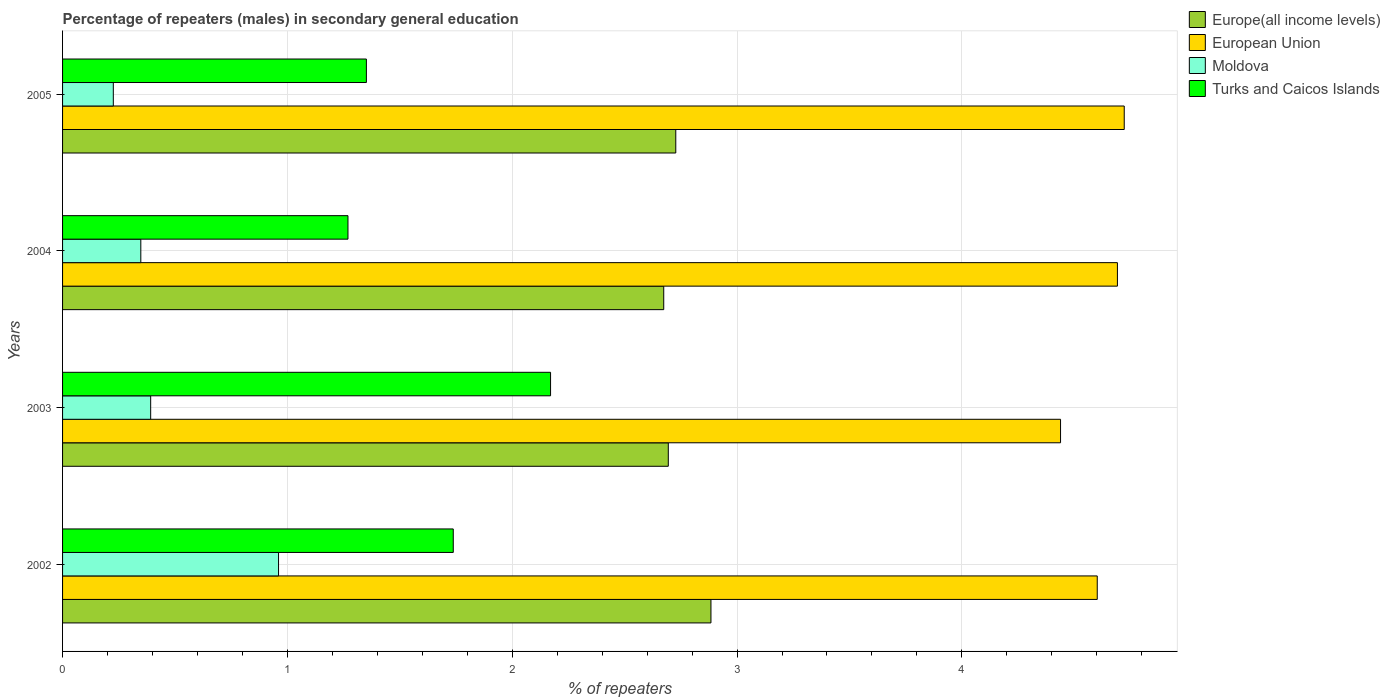Are the number of bars per tick equal to the number of legend labels?
Provide a short and direct response. Yes. Are the number of bars on each tick of the Y-axis equal?
Your answer should be very brief. Yes. How many bars are there on the 4th tick from the bottom?
Provide a succinct answer. 4. In how many cases, is the number of bars for a given year not equal to the number of legend labels?
Offer a very short reply. 0. What is the percentage of male repeaters in Moldova in 2005?
Offer a terse response. 0.23. Across all years, what is the maximum percentage of male repeaters in European Union?
Keep it short and to the point. 4.72. Across all years, what is the minimum percentage of male repeaters in European Union?
Give a very brief answer. 4.44. In which year was the percentage of male repeaters in Turks and Caicos Islands minimum?
Keep it short and to the point. 2004. What is the total percentage of male repeaters in Europe(all income levels) in the graph?
Make the answer very short. 10.98. What is the difference between the percentage of male repeaters in Moldova in 2003 and that in 2005?
Your response must be concise. 0.17. What is the difference between the percentage of male repeaters in Turks and Caicos Islands in 2005 and the percentage of male repeaters in Moldova in 2002?
Ensure brevity in your answer.  0.39. What is the average percentage of male repeaters in Turks and Caicos Islands per year?
Your answer should be very brief. 1.63. In the year 2003, what is the difference between the percentage of male repeaters in Moldova and percentage of male repeaters in European Union?
Provide a short and direct response. -4.05. What is the ratio of the percentage of male repeaters in Moldova in 2004 to that in 2005?
Give a very brief answer. 1.54. What is the difference between the highest and the second highest percentage of male repeaters in Moldova?
Provide a short and direct response. 0.57. What is the difference between the highest and the lowest percentage of male repeaters in Turks and Caicos Islands?
Keep it short and to the point. 0.9. Is the sum of the percentage of male repeaters in Moldova in 2002 and 2004 greater than the maximum percentage of male repeaters in European Union across all years?
Make the answer very short. No. What does the 2nd bar from the top in 2003 represents?
Your answer should be very brief. Moldova. Is it the case that in every year, the sum of the percentage of male repeaters in Turks and Caicos Islands and percentage of male repeaters in Moldova is greater than the percentage of male repeaters in Europe(all income levels)?
Your answer should be compact. No. How many bars are there?
Provide a short and direct response. 16. What is the difference between two consecutive major ticks on the X-axis?
Make the answer very short. 1. Are the values on the major ticks of X-axis written in scientific E-notation?
Your answer should be compact. No. Does the graph contain any zero values?
Keep it short and to the point. No. Does the graph contain grids?
Provide a succinct answer. Yes. Where does the legend appear in the graph?
Keep it short and to the point. Top right. How many legend labels are there?
Your response must be concise. 4. How are the legend labels stacked?
Make the answer very short. Vertical. What is the title of the graph?
Keep it short and to the point. Percentage of repeaters (males) in secondary general education. What is the label or title of the X-axis?
Provide a succinct answer. % of repeaters. What is the label or title of the Y-axis?
Your answer should be compact. Years. What is the % of repeaters in Europe(all income levels) in 2002?
Make the answer very short. 2.88. What is the % of repeaters of European Union in 2002?
Ensure brevity in your answer.  4.6. What is the % of repeaters of Moldova in 2002?
Provide a succinct answer. 0.96. What is the % of repeaters in Turks and Caicos Islands in 2002?
Offer a terse response. 1.74. What is the % of repeaters of Europe(all income levels) in 2003?
Your answer should be very brief. 2.69. What is the % of repeaters of European Union in 2003?
Ensure brevity in your answer.  4.44. What is the % of repeaters of Moldova in 2003?
Keep it short and to the point. 0.39. What is the % of repeaters of Turks and Caicos Islands in 2003?
Keep it short and to the point. 2.17. What is the % of repeaters in Europe(all income levels) in 2004?
Your answer should be compact. 2.67. What is the % of repeaters of European Union in 2004?
Make the answer very short. 4.69. What is the % of repeaters of Moldova in 2004?
Provide a succinct answer. 0.35. What is the % of repeaters in Turks and Caicos Islands in 2004?
Provide a short and direct response. 1.27. What is the % of repeaters of Europe(all income levels) in 2005?
Your answer should be very brief. 2.73. What is the % of repeaters in European Union in 2005?
Provide a short and direct response. 4.72. What is the % of repeaters of Moldova in 2005?
Provide a succinct answer. 0.23. What is the % of repeaters in Turks and Caicos Islands in 2005?
Make the answer very short. 1.35. Across all years, what is the maximum % of repeaters in Europe(all income levels)?
Keep it short and to the point. 2.88. Across all years, what is the maximum % of repeaters in European Union?
Offer a terse response. 4.72. Across all years, what is the maximum % of repeaters of Moldova?
Offer a very short reply. 0.96. Across all years, what is the maximum % of repeaters in Turks and Caicos Islands?
Give a very brief answer. 2.17. Across all years, what is the minimum % of repeaters of Europe(all income levels)?
Your response must be concise. 2.67. Across all years, what is the minimum % of repeaters in European Union?
Your response must be concise. 4.44. Across all years, what is the minimum % of repeaters in Moldova?
Your answer should be compact. 0.23. Across all years, what is the minimum % of repeaters in Turks and Caicos Islands?
Give a very brief answer. 1.27. What is the total % of repeaters in Europe(all income levels) in the graph?
Your answer should be compact. 10.98. What is the total % of repeaters of European Union in the graph?
Give a very brief answer. 18.45. What is the total % of repeaters in Moldova in the graph?
Offer a terse response. 1.93. What is the total % of repeaters of Turks and Caicos Islands in the graph?
Offer a very short reply. 6.53. What is the difference between the % of repeaters of Europe(all income levels) in 2002 and that in 2003?
Provide a succinct answer. 0.19. What is the difference between the % of repeaters in European Union in 2002 and that in 2003?
Your answer should be very brief. 0.16. What is the difference between the % of repeaters of Moldova in 2002 and that in 2003?
Keep it short and to the point. 0.57. What is the difference between the % of repeaters in Turks and Caicos Islands in 2002 and that in 2003?
Ensure brevity in your answer.  -0.43. What is the difference between the % of repeaters of Europe(all income levels) in 2002 and that in 2004?
Your response must be concise. 0.21. What is the difference between the % of repeaters of European Union in 2002 and that in 2004?
Your answer should be compact. -0.09. What is the difference between the % of repeaters in Moldova in 2002 and that in 2004?
Give a very brief answer. 0.61. What is the difference between the % of repeaters in Turks and Caicos Islands in 2002 and that in 2004?
Ensure brevity in your answer.  0.47. What is the difference between the % of repeaters of Europe(all income levels) in 2002 and that in 2005?
Give a very brief answer. 0.16. What is the difference between the % of repeaters in European Union in 2002 and that in 2005?
Offer a very short reply. -0.12. What is the difference between the % of repeaters in Moldova in 2002 and that in 2005?
Your response must be concise. 0.73. What is the difference between the % of repeaters of Turks and Caicos Islands in 2002 and that in 2005?
Your response must be concise. 0.39. What is the difference between the % of repeaters in Europe(all income levels) in 2003 and that in 2004?
Provide a succinct answer. 0.02. What is the difference between the % of repeaters in European Union in 2003 and that in 2004?
Your answer should be very brief. -0.25. What is the difference between the % of repeaters of Moldova in 2003 and that in 2004?
Your answer should be very brief. 0.04. What is the difference between the % of repeaters in Turks and Caicos Islands in 2003 and that in 2004?
Your answer should be compact. 0.9. What is the difference between the % of repeaters in Europe(all income levels) in 2003 and that in 2005?
Your answer should be very brief. -0.03. What is the difference between the % of repeaters of European Union in 2003 and that in 2005?
Make the answer very short. -0.28. What is the difference between the % of repeaters in Moldova in 2003 and that in 2005?
Your response must be concise. 0.17. What is the difference between the % of repeaters of Turks and Caicos Islands in 2003 and that in 2005?
Offer a very short reply. 0.82. What is the difference between the % of repeaters of Europe(all income levels) in 2004 and that in 2005?
Provide a short and direct response. -0.05. What is the difference between the % of repeaters in European Union in 2004 and that in 2005?
Your response must be concise. -0.03. What is the difference between the % of repeaters of Moldova in 2004 and that in 2005?
Offer a terse response. 0.12. What is the difference between the % of repeaters of Turks and Caicos Islands in 2004 and that in 2005?
Your answer should be compact. -0.08. What is the difference between the % of repeaters of Europe(all income levels) in 2002 and the % of repeaters of European Union in 2003?
Your answer should be very brief. -1.55. What is the difference between the % of repeaters in Europe(all income levels) in 2002 and the % of repeaters in Moldova in 2003?
Keep it short and to the point. 2.49. What is the difference between the % of repeaters of Europe(all income levels) in 2002 and the % of repeaters of Turks and Caicos Islands in 2003?
Your response must be concise. 0.71. What is the difference between the % of repeaters of European Union in 2002 and the % of repeaters of Moldova in 2003?
Give a very brief answer. 4.21. What is the difference between the % of repeaters in European Union in 2002 and the % of repeaters in Turks and Caicos Islands in 2003?
Make the answer very short. 2.43. What is the difference between the % of repeaters in Moldova in 2002 and the % of repeaters in Turks and Caicos Islands in 2003?
Provide a succinct answer. -1.21. What is the difference between the % of repeaters of Europe(all income levels) in 2002 and the % of repeaters of European Union in 2004?
Provide a short and direct response. -1.81. What is the difference between the % of repeaters in Europe(all income levels) in 2002 and the % of repeaters in Moldova in 2004?
Provide a short and direct response. 2.54. What is the difference between the % of repeaters of Europe(all income levels) in 2002 and the % of repeaters of Turks and Caicos Islands in 2004?
Offer a terse response. 1.61. What is the difference between the % of repeaters of European Union in 2002 and the % of repeaters of Moldova in 2004?
Your answer should be compact. 4.25. What is the difference between the % of repeaters in European Union in 2002 and the % of repeaters in Turks and Caicos Islands in 2004?
Your answer should be very brief. 3.33. What is the difference between the % of repeaters in Moldova in 2002 and the % of repeaters in Turks and Caicos Islands in 2004?
Give a very brief answer. -0.31. What is the difference between the % of repeaters of Europe(all income levels) in 2002 and the % of repeaters of European Union in 2005?
Offer a very short reply. -1.84. What is the difference between the % of repeaters of Europe(all income levels) in 2002 and the % of repeaters of Moldova in 2005?
Provide a short and direct response. 2.66. What is the difference between the % of repeaters in Europe(all income levels) in 2002 and the % of repeaters in Turks and Caicos Islands in 2005?
Provide a succinct answer. 1.53. What is the difference between the % of repeaters of European Union in 2002 and the % of repeaters of Moldova in 2005?
Keep it short and to the point. 4.38. What is the difference between the % of repeaters in European Union in 2002 and the % of repeaters in Turks and Caicos Islands in 2005?
Provide a succinct answer. 3.25. What is the difference between the % of repeaters of Moldova in 2002 and the % of repeaters of Turks and Caicos Islands in 2005?
Give a very brief answer. -0.39. What is the difference between the % of repeaters of Europe(all income levels) in 2003 and the % of repeaters of European Union in 2004?
Your answer should be very brief. -2. What is the difference between the % of repeaters in Europe(all income levels) in 2003 and the % of repeaters in Moldova in 2004?
Provide a short and direct response. 2.35. What is the difference between the % of repeaters of Europe(all income levels) in 2003 and the % of repeaters of Turks and Caicos Islands in 2004?
Your answer should be compact. 1.42. What is the difference between the % of repeaters in European Union in 2003 and the % of repeaters in Moldova in 2004?
Make the answer very short. 4.09. What is the difference between the % of repeaters of European Union in 2003 and the % of repeaters of Turks and Caicos Islands in 2004?
Your answer should be compact. 3.17. What is the difference between the % of repeaters of Moldova in 2003 and the % of repeaters of Turks and Caicos Islands in 2004?
Your answer should be compact. -0.88. What is the difference between the % of repeaters of Europe(all income levels) in 2003 and the % of repeaters of European Union in 2005?
Give a very brief answer. -2.03. What is the difference between the % of repeaters in Europe(all income levels) in 2003 and the % of repeaters in Moldova in 2005?
Ensure brevity in your answer.  2.47. What is the difference between the % of repeaters in Europe(all income levels) in 2003 and the % of repeaters in Turks and Caicos Islands in 2005?
Your response must be concise. 1.34. What is the difference between the % of repeaters in European Union in 2003 and the % of repeaters in Moldova in 2005?
Provide a short and direct response. 4.21. What is the difference between the % of repeaters in European Union in 2003 and the % of repeaters in Turks and Caicos Islands in 2005?
Your answer should be very brief. 3.09. What is the difference between the % of repeaters of Moldova in 2003 and the % of repeaters of Turks and Caicos Islands in 2005?
Your answer should be compact. -0.96. What is the difference between the % of repeaters in Europe(all income levels) in 2004 and the % of repeaters in European Union in 2005?
Your answer should be very brief. -2.05. What is the difference between the % of repeaters of Europe(all income levels) in 2004 and the % of repeaters of Moldova in 2005?
Your answer should be very brief. 2.45. What is the difference between the % of repeaters in Europe(all income levels) in 2004 and the % of repeaters in Turks and Caicos Islands in 2005?
Your response must be concise. 1.32. What is the difference between the % of repeaters of European Union in 2004 and the % of repeaters of Moldova in 2005?
Provide a succinct answer. 4.47. What is the difference between the % of repeaters in European Union in 2004 and the % of repeaters in Turks and Caicos Islands in 2005?
Ensure brevity in your answer.  3.34. What is the difference between the % of repeaters in Moldova in 2004 and the % of repeaters in Turks and Caicos Islands in 2005?
Your answer should be compact. -1. What is the average % of repeaters of Europe(all income levels) per year?
Your response must be concise. 2.74. What is the average % of repeaters of European Union per year?
Provide a succinct answer. 4.61. What is the average % of repeaters of Moldova per year?
Your answer should be compact. 0.48. What is the average % of repeaters of Turks and Caicos Islands per year?
Your answer should be very brief. 1.63. In the year 2002, what is the difference between the % of repeaters of Europe(all income levels) and % of repeaters of European Union?
Ensure brevity in your answer.  -1.72. In the year 2002, what is the difference between the % of repeaters of Europe(all income levels) and % of repeaters of Moldova?
Your answer should be compact. 1.92. In the year 2002, what is the difference between the % of repeaters of Europe(all income levels) and % of repeaters of Turks and Caicos Islands?
Give a very brief answer. 1.15. In the year 2002, what is the difference between the % of repeaters of European Union and % of repeaters of Moldova?
Your answer should be compact. 3.64. In the year 2002, what is the difference between the % of repeaters of European Union and % of repeaters of Turks and Caicos Islands?
Make the answer very short. 2.86. In the year 2002, what is the difference between the % of repeaters in Moldova and % of repeaters in Turks and Caicos Islands?
Your answer should be very brief. -0.78. In the year 2003, what is the difference between the % of repeaters in Europe(all income levels) and % of repeaters in European Union?
Your response must be concise. -1.74. In the year 2003, what is the difference between the % of repeaters of Europe(all income levels) and % of repeaters of Moldova?
Provide a succinct answer. 2.3. In the year 2003, what is the difference between the % of repeaters in Europe(all income levels) and % of repeaters in Turks and Caicos Islands?
Offer a terse response. 0.52. In the year 2003, what is the difference between the % of repeaters of European Union and % of repeaters of Moldova?
Offer a very short reply. 4.05. In the year 2003, what is the difference between the % of repeaters of European Union and % of repeaters of Turks and Caicos Islands?
Offer a terse response. 2.27. In the year 2003, what is the difference between the % of repeaters in Moldova and % of repeaters in Turks and Caicos Islands?
Ensure brevity in your answer.  -1.78. In the year 2004, what is the difference between the % of repeaters in Europe(all income levels) and % of repeaters in European Union?
Your response must be concise. -2.02. In the year 2004, what is the difference between the % of repeaters of Europe(all income levels) and % of repeaters of Moldova?
Keep it short and to the point. 2.33. In the year 2004, what is the difference between the % of repeaters of Europe(all income levels) and % of repeaters of Turks and Caicos Islands?
Give a very brief answer. 1.4. In the year 2004, what is the difference between the % of repeaters of European Union and % of repeaters of Moldova?
Provide a succinct answer. 4.34. In the year 2004, what is the difference between the % of repeaters of European Union and % of repeaters of Turks and Caicos Islands?
Make the answer very short. 3.42. In the year 2004, what is the difference between the % of repeaters of Moldova and % of repeaters of Turks and Caicos Islands?
Provide a short and direct response. -0.92. In the year 2005, what is the difference between the % of repeaters of Europe(all income levels) and % of repeaters of European Union?
Provide a succinct answer. -1.99. In the year 2005, what is the difference between the % of repeaters of Europe(all income levels) and % of repeaters of Moldova?
Make the answer very short. 2.5. In the year 2005, what is the difference between the % of repeaters of Europe(all income levels) and % of repeaters of Turks and Caicos Islands?
Make the answer very short. 1.38. In the year 2005, what is the difference between the % of repeaters in European Union and % of repeaters in Moldova?
Provide a short and direct response. 4.5. In the year 2005, what is the difference between the % of repeaters in European Union and % of repeaters in Turks and Caicos Islands?
Your answer should be very brief. 3.37. In the year 2005, what is the difference between the % of repeaters of Moldova and % of repeaters of Turks and Caicos Islands?
Ensure brevity in your answer.  -1.13. What is the ratio of the % of repeaters in Europe(all income levels) in 2002 to that in 2003?
Your answer should be very brief. 1.07. What is the ratio of the % of repeaters of European Union in 2002 to that in 2003?
Make the answer very short. 1.04. What is the ratio of the % of repeaters in Moldova in 2002 to that in 2003?
Ensure brevity in your answer.  2.45. What is the ratio of the % of repeaters in Turks and Caicos Islands in 2002 to that in 2003?
Offer a very short reply. 0.8. What is the ratio of the % of repeaters in Europe(all income levels) in 2002 to that in 2004?
Give a very brief answer. 1.08. What is the ratio of the % of repeaters of European Union in 2002 to that in 2004?
Give a very brief answer. 0.98. What is the ratio of the % of repeaters in Moldova in 2002 to that in 2004?
Offer a terse response. 2.76. What is the ratio of the % of repeaters in Turks and Caicos Islands in 2002 to that in 2004?
Your answer should be compact. 1.37. What is the ratio of the % of repeaters in Europe(all income levels) in 2002 to that in 2005?
Your response must be concise. 1.06. What is the ratio of the % of repeaters of European Union in 2002 to that in 2005?
Provide a succinct answer. 0.97. What is the ratio of the % of repeaters in Moldova in 2002 to that in 2005?
Ensure brevity in your answer.  4.26. What is the ratio of the % of repeaters in Turks and Caicos Islands in 2002 to that in 2005?
Offer a terse response. 1.29. What is the ratio of the % of repeaters of Europe(all income levels) in 2003 to that in 2004?
Ensure brevity in your answer.  1.01. What is the ratio of the % of repeaters of European Union in 2003 to that in 2004?
Make the answer very short. 0.95. What is the ratio of the % of repeaters in Moldova in 2003 to that in 2004?
Keep it short and to the point. 1.13. What is the ratio of the % of repeaters in Turks and Caicos Islands in 2003 to that in 2004?
Your answer should be very brief. 1.71. What is the ratio of the % of repeaters of Moldova in 2003 to that in 2005?
Your answer should be compact. 1.74. What is the ratio of the % of repeaters in Turks and Caicos Islands in 2003 to that in 2005?
Your answer should be compact. 1.61. What is the ratio of the % of repeaters in Europe(all income levels) in 2004 to that in 2005?
Your answer should be compact. 0.98. What is the ratio of the % of repeaters of European Union in 2004 to that in 2005?
Give a very brief answer. 0.99. What is the ratio of the % of repeaters of Moldova in 2004 to that in 2005?
Keep it short and to the point. 1.54. What is the ratio of the % of repeaters of Turks and Caicos Islands in 2004 to that in 2005?
Keep it short and to the point. 0.94. What is the difference between the highest and the second highest % of repeaters in Europe(all income levels)?
Provide a short and direct response. 0.16. What is the difference between the highest and the second highest % of repeaters in European Union?
Provide a succinct answer. 0.03. What is the difference between the highest and the second highest % of repeaters in Moldova?
Provide a succinct answer. 0.57. What is the difference between the highest and the second highest % of repeaters of Turks and Caicos Islands?
Your answer should be very brief. 0.43. What is the difference between the highest and the lowest % of repeaters in Europe(all income levels)?
Your response must be concise. 0.21. What is the difference between the highest and the lowest % of repeaters of European Union?
Your answer should be very brief. 0.28. What is the difference between the highest and the lowest % of repeaters of Moldova?
Your answer should be compact. 0.73. What is the difference between the highest and the lowest % of repeaters in Turks and Caicos Islands?
Keep it short and to the point. 0.9. 